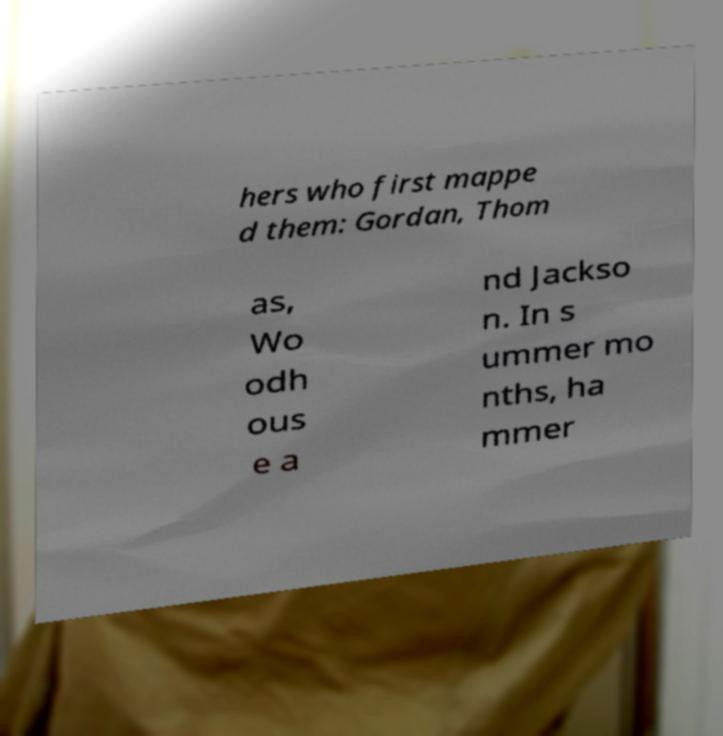Could you assist in decoding the text presented in this image and type it out clearly? hers who first mappe d them: Gordan, Thom as, Wo odh ous e a nd Jackso n. In s ummer mo nths, ha mmer 